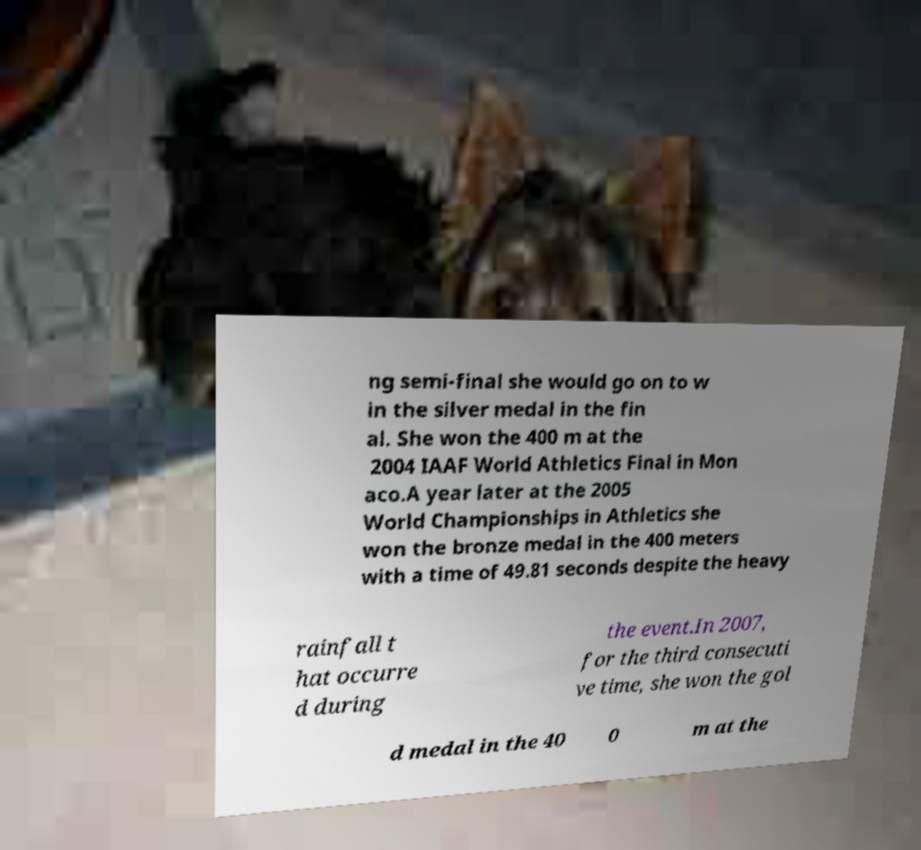Could you assist in decoding the text presented in this image and type it out clearly? ng semi-final she would go on to w in the silver medal in the fin al. She won the 400 m at the 2004 IAAF World Athletics Final in Mon aco.A year later at the 2005 World Championships in Athletics she won the bronze medal in the 400 meters with a time of 49.81 seconds despite the heavy rainfall t hat occurre d during the event.In 2007, for the third consecuti ve time, she won the gol d medal in the 40 0 m at the 